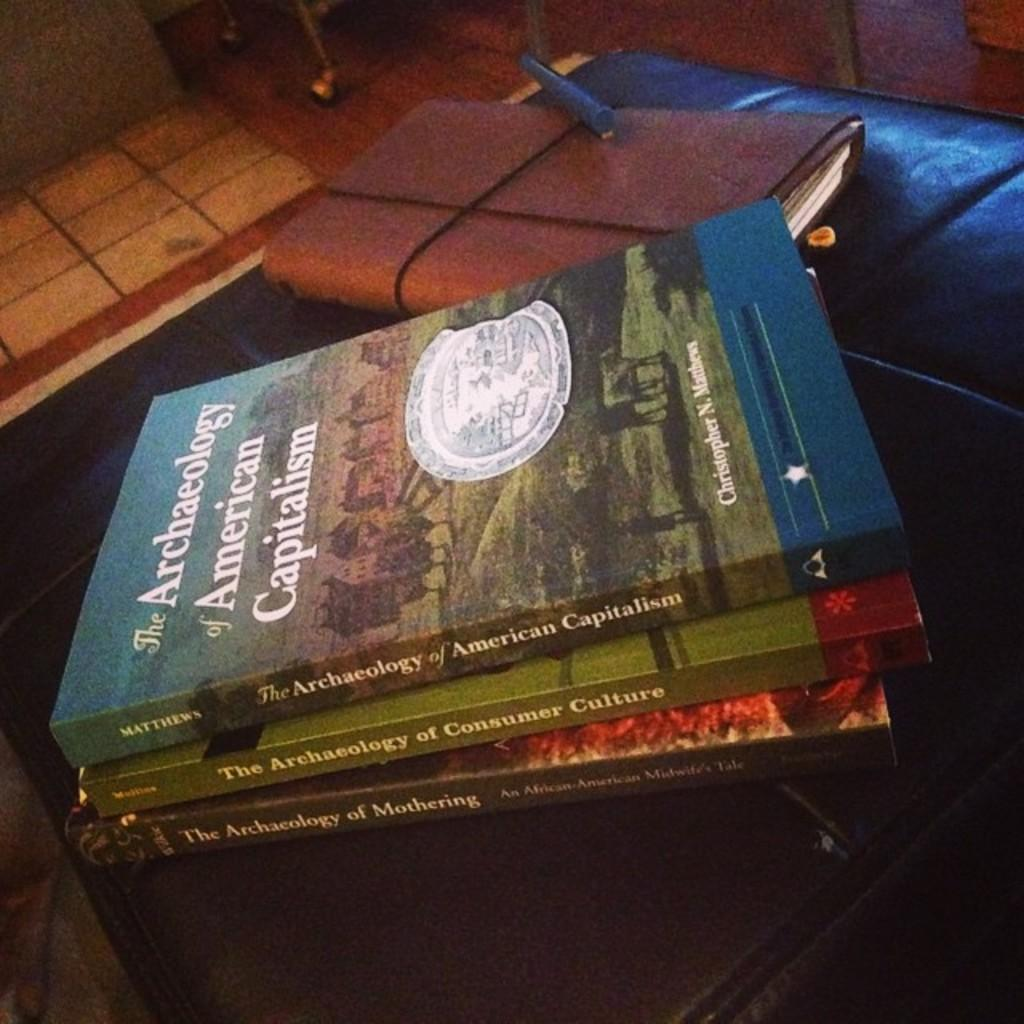Provide a one-sentence caption for the provided image. Three Archaeology books are stacked in a pile. 